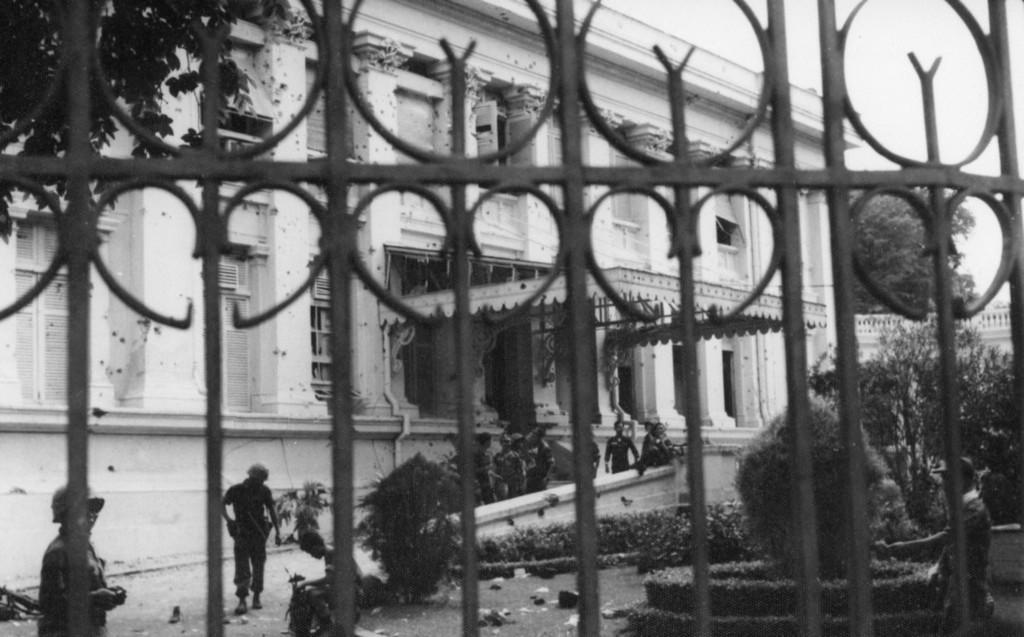Could you give a brief overview of what you see in this image? In the foreground I can see a fence, plants, trees and group of people on the road. In the background I can see a building, windows and the sky. This image is taken during a day. 